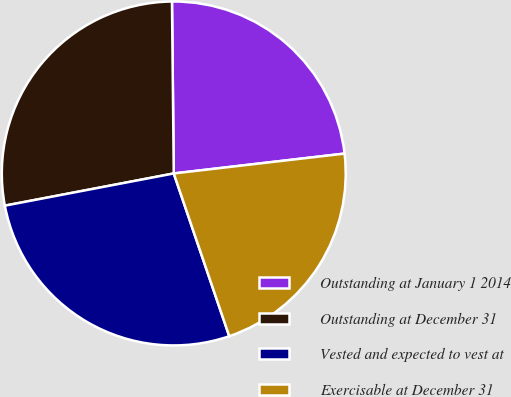Convert chart to OTSL. <chart><loc_0><loc_0><loc_500><loc_500><pie_chart><fcel>Outstanding at January 1 2014<fcel>Outstanding at December 31<fcel>Vested and expected to vest at<fcel>Exercisable at December 31<nl><fcel>23.32%<fcel>27.83%<fcel>27.23%<fcel>21.61%<nl></chart> 